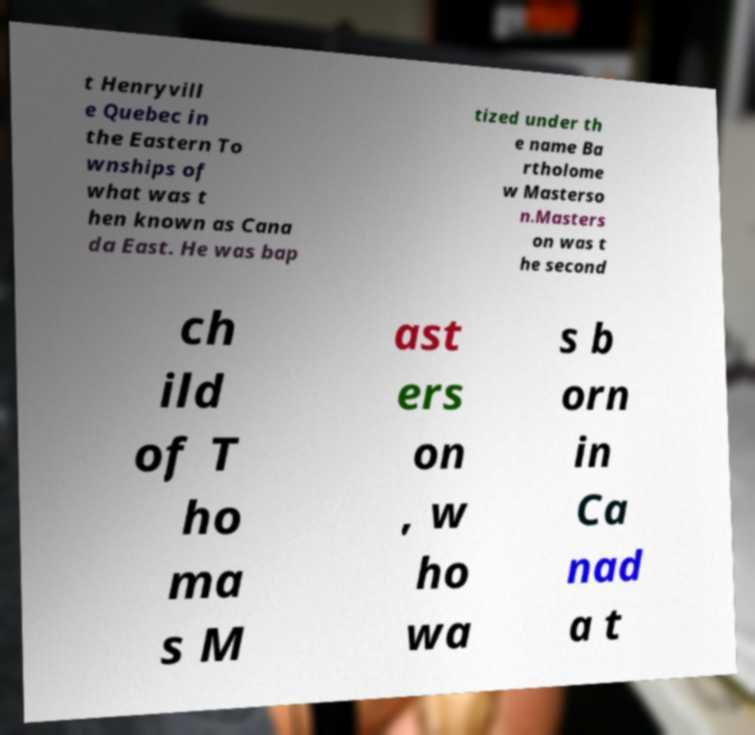For documentation purposes, I need the text within this image transcribed. Could you provide that? t Henryvill e Quebec in the Eastern To wnships of what was t hen known as Cana da East. He was bap tized under th e name Ba rtholome w Masterso n.Masters on was t he second ch ild of T ho ma s M ast ers on , w ho wa s b orn in Ca nad a t 